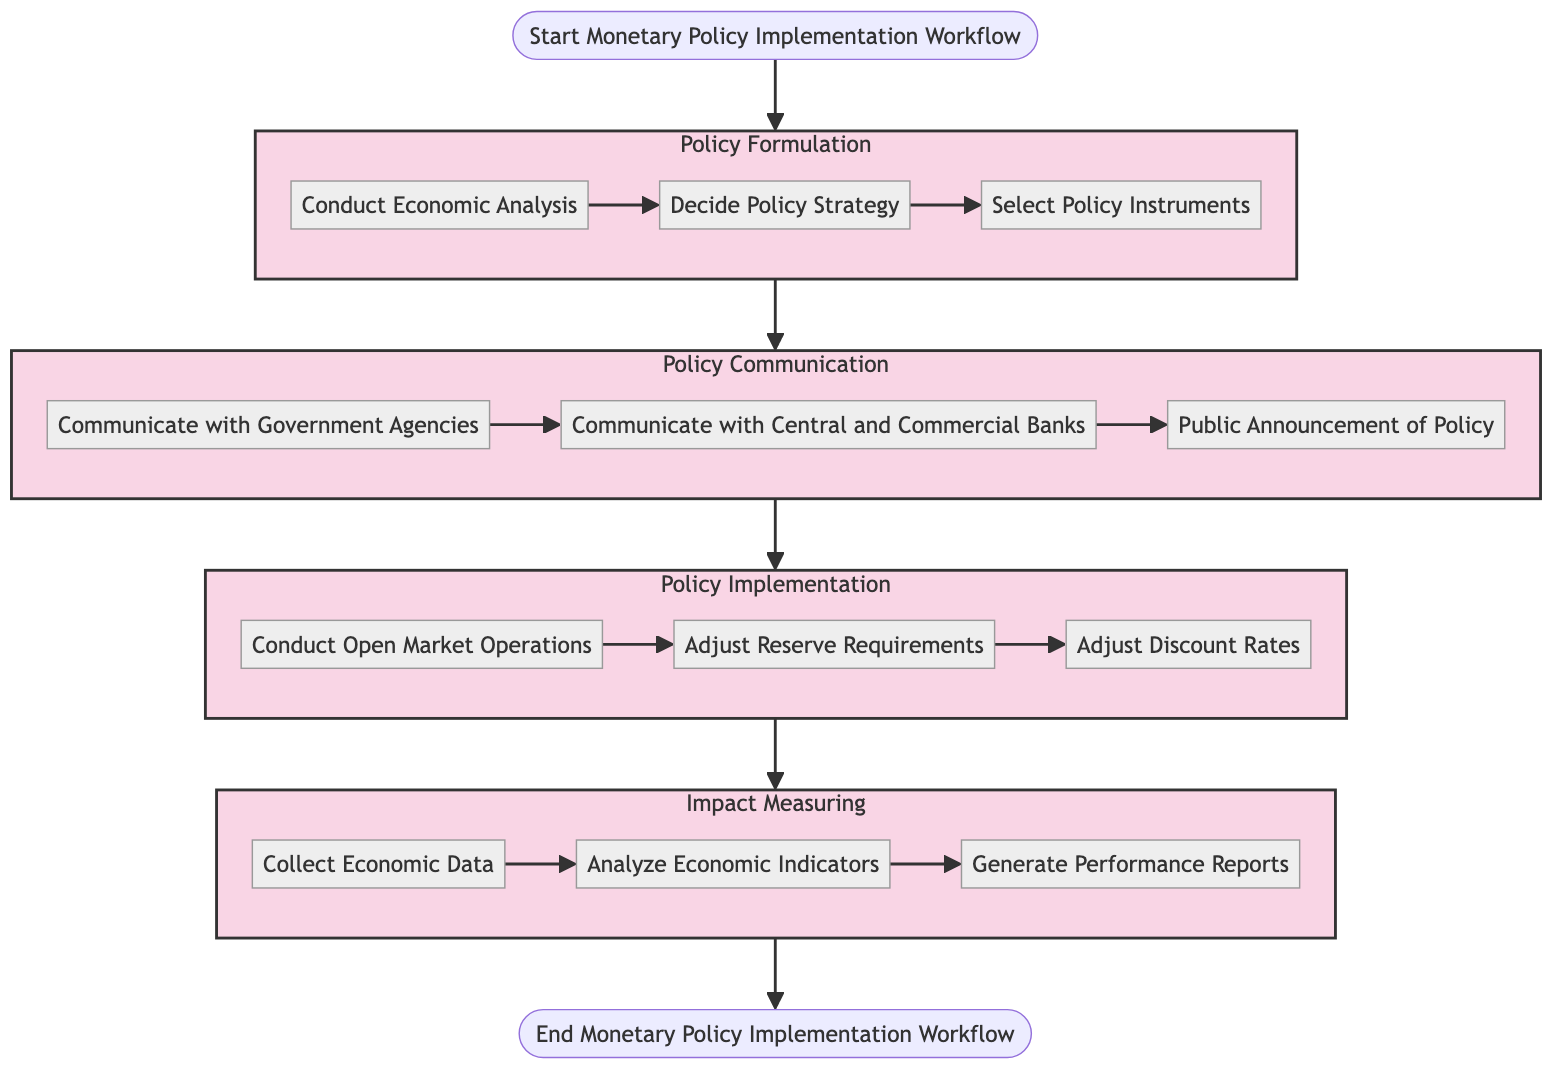What is the first stage of the workflow? The diagram indicates that the workflow begins with the "Formulate Monetary Policy" stage. It is the first stage connected directly from the "Start" node.
Answer: Formulate Monetary Policy How many steps are in the "Policy Implementation" stage? In the "Policy Implementation" stage, there are three steps: "Conduct Open Market Operations," "Adjust Reserve Requirements," and "Adjust Discount Rates." Thus, the total number of steps is three.
Answer: 3 What is the last step before concluding the workflow? The last step before the "End" node is "Generate Performance Reports," which is part of the "Impact Measuring" stage and connected from the "Analyze Economic Indicators."
Answer: Generate Performance Reports Which step follows "Decide Policy Strategy"? The step that follows "Decide Policy Strategy" within the "Policy Formulation" stage is "Select Policy Instruments." This is established by the direct flow from one step to the next.
Answer: Select Policy Instruments What are the three steps in the "Impact Measuring" stage? The "Impact Measuring" stage contains three steps: "Collect Economic Data," "Analyze Economic Indicators," and "Generate Performance Reports." These steps are listed sequentially within that stage.
Answer: Collect Economic Data, Analyze Economic Indicators, Generate Performance Reports What is the relationship between "Communicate with Central and Commercial Banks" and "Public Announcement of Policy"? The diagram shows that "Communicate with Central and Commercial Banks" directly precedes "Public Announcement of Policy," indicating that communication goes to banks before announcing the policy publicly.
Answer: Sequential relationship How does the workflow transition from policy formulation to policy communication? The transition from "Policy Formulation" to "Policy Communication" occurs after all steps in the "Policy Formulation" stage are completed. Therefore, the policy communication starts only after the formulation is finalized.
Answer: After completion of Policy Formulation What is a step in the "Policy Communication" stage that addresses government involvement? The step that involves government involvement in the "Policy Communication" stage is "Communicate with Government Agencies," which indicates interaction with governmental bodies regarding policy measures.
Answer: Communicate with Government Agencies How many total stages are represented in the diagram? The diagram includes four stages: "Policy Formulation," "Policy Communication," "Policy Implementation," and "Impact Measuring." By reviewing the subgraphs, the count of distinct stages can be confirmed.
Answer: 4 